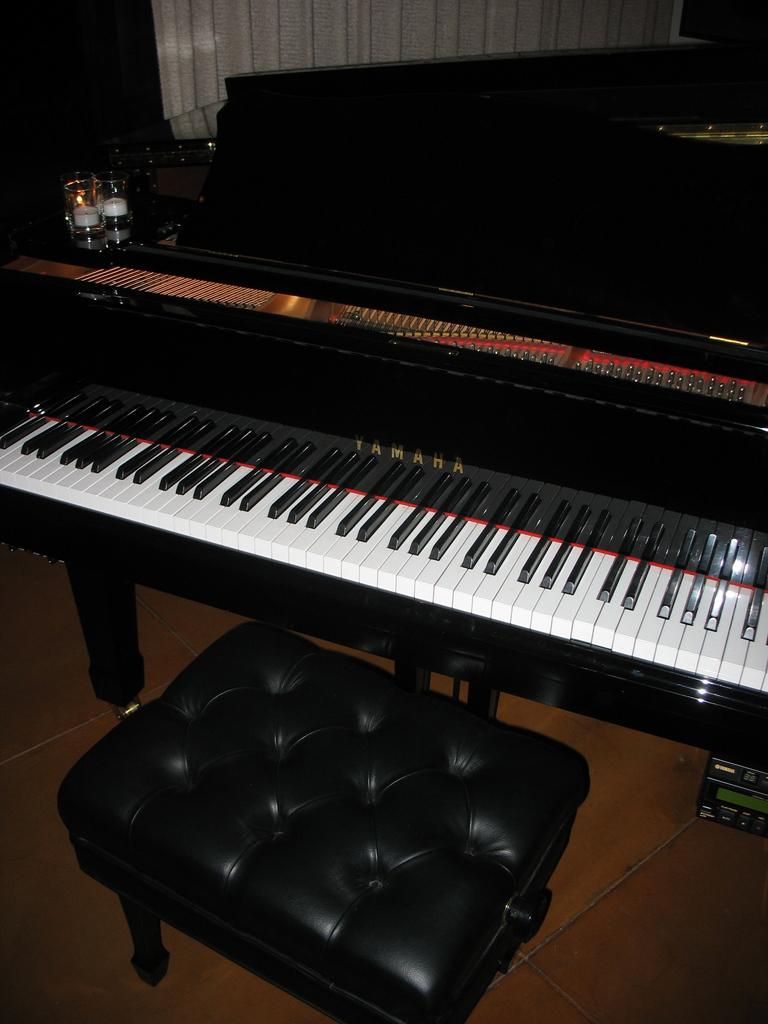What object in the image is typically used for drinking? There is a glass in the image, which is typically used for drinking. What object in the image is used for creating music? There is a musical keyboard in the image, which is used for creating music. How many cacti can be seen in the image? There are no cacti present in the image. What type of boys are playing with the musical keyboard in the image? There are no boys present in the image; it only features a glass and a musical keyboard. 